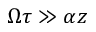<formula> <loc_0><loc_0><loc_500><loc_500>\Omega \tau \gg \alpha z</formula> 